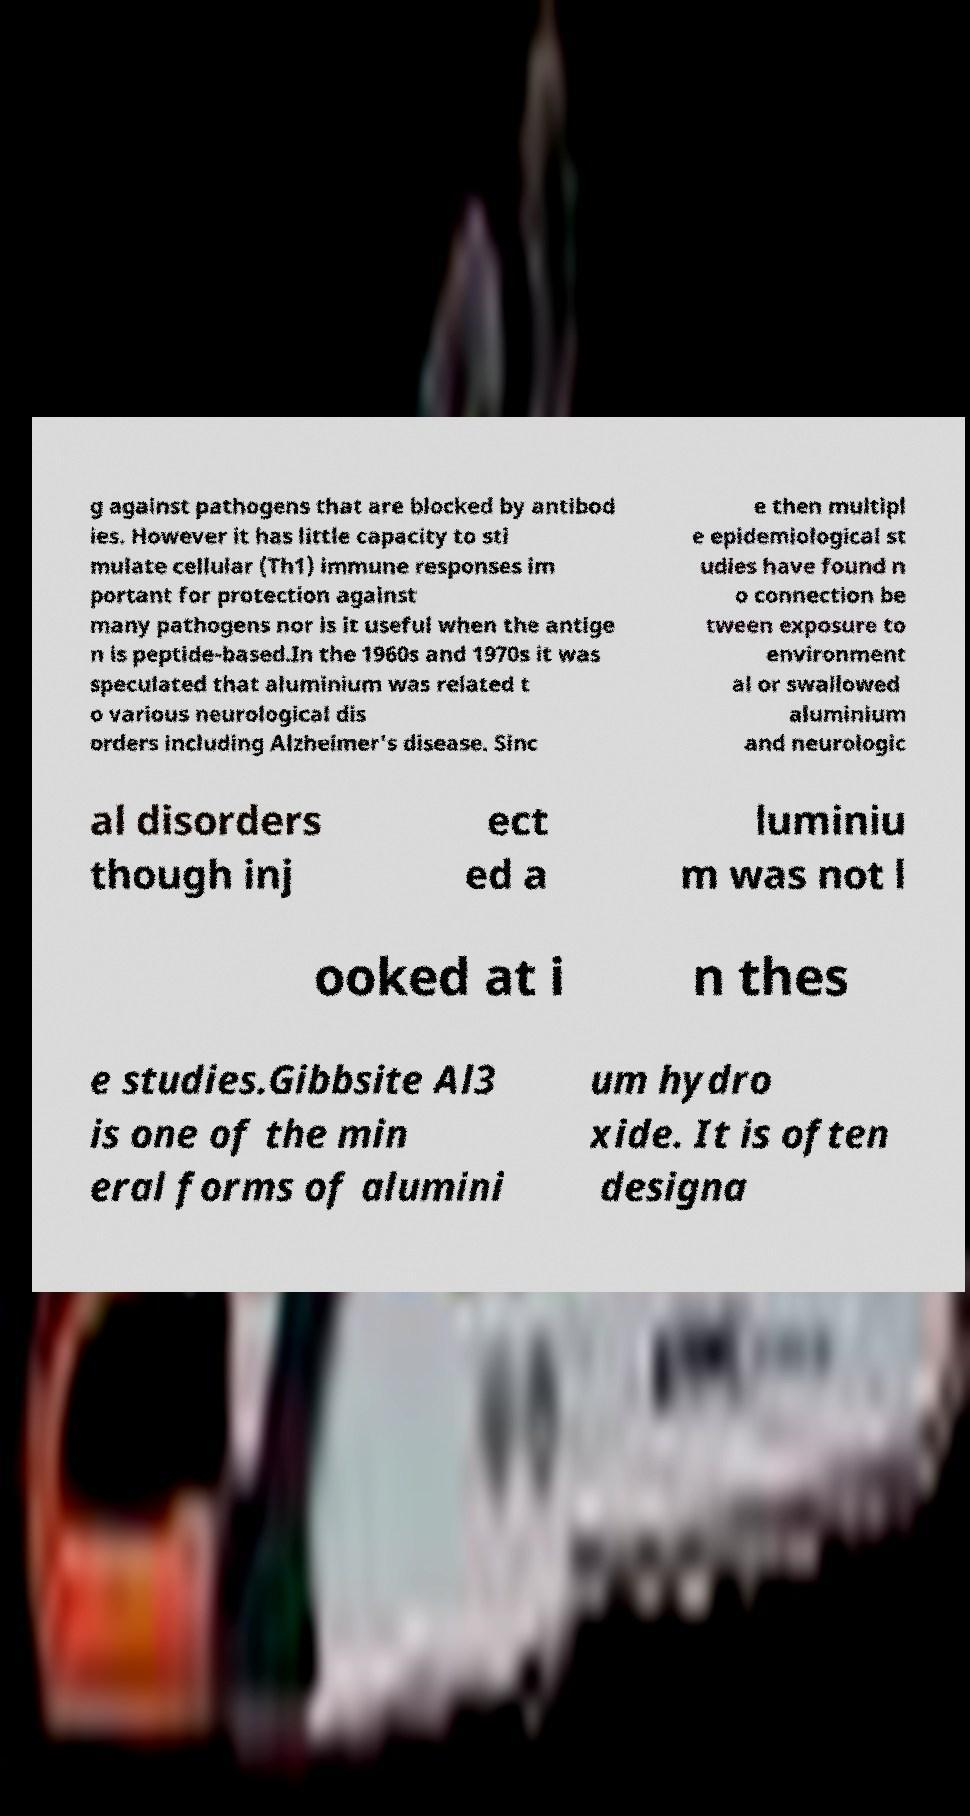Can you read and provide the text displayed in the image?This photo seems to have some interesting text. Can you extract and type it out for me? g against pathogens that are blocked by antibod ies. However it has little capacity to sti mulate cellular (Th1) immune responses im portant for protection against many pathogens nor is it useful when the antige n is peptide-based.In the 1960s and 1970s it was speculated that aluminium was related t o various neurological dis orders including Alzheimer's disease. Sinc e then multipl e epidemiological st udies have found n o connection be tween exposure to environment al or swallowed aluminium and neurologic al disorders though inj ect ed a luminiu m was not l ooked at i n thes e studies.Gibbsite Al3 is one of the min eral forms of alumini um hydro xide. It is often designa 